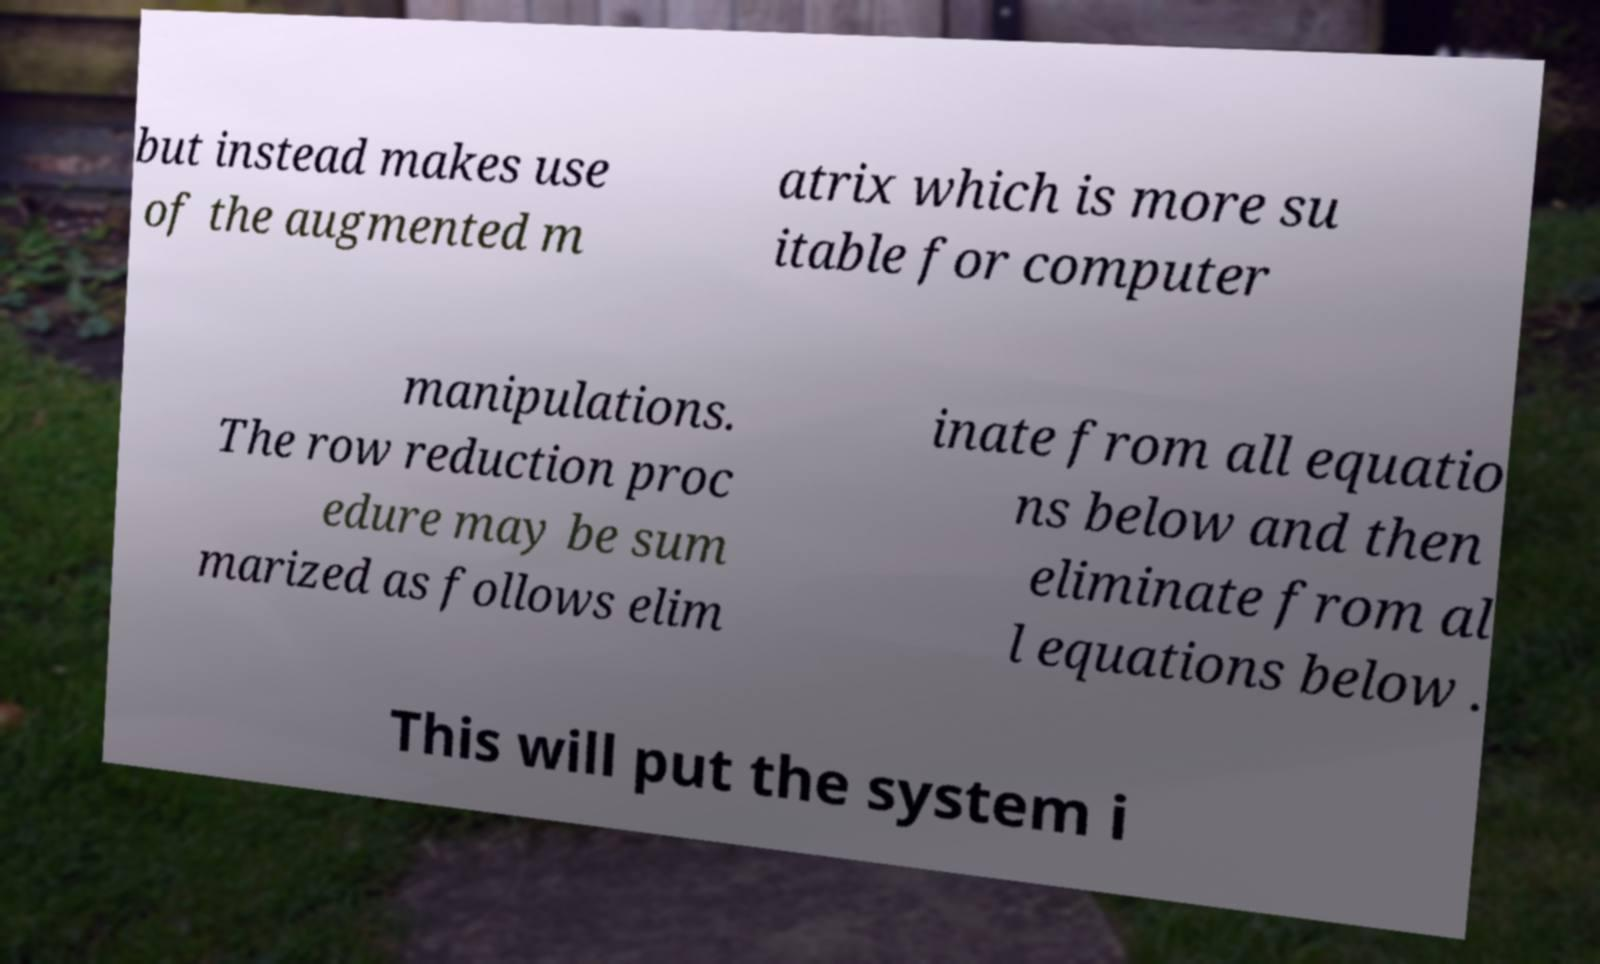For documentation purposes, I need the text within this image transcribed. Could you provide that? but instead makes use of the augmented m atrix which is more su itable for computer manipulations. The row reduction proc edure may be sum marized as follows elim inate from all equatio ns below and then eliminate from al l equations below . This will put the system i 